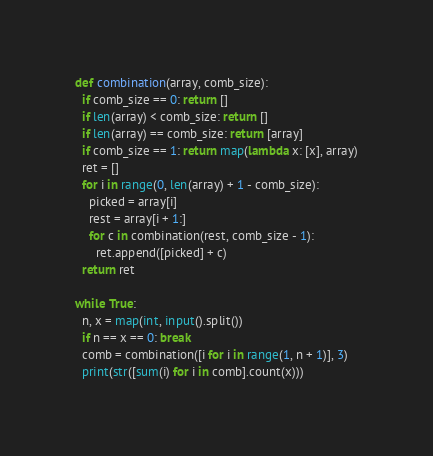<code> <loc_0><loc_0><loc_500><loc_500><_Python_>def combination(array, comb_size):
  if comb_size == 0: return []
  if len(array) < comb_size: return []
  if len(array) == comb_size: return [array]
  if comb_size == 1: return map(lambda x: [x], array)
  ret = []
  for i in range(0, len(array) + 1 - comb_size):
    picked = array[i]
    rest = array[i + 1:]
    for c in combination(rest, comb_size - 1):
      ret.append([picked] + c)
  return ret

while True:
  n, x = map(int, input().split())
  if n == x == 0: break
  comb = combination([i for i in range(1, n + 1)], 3)
  print(str([sum(i) for i in comb].count(x)))
</code> 